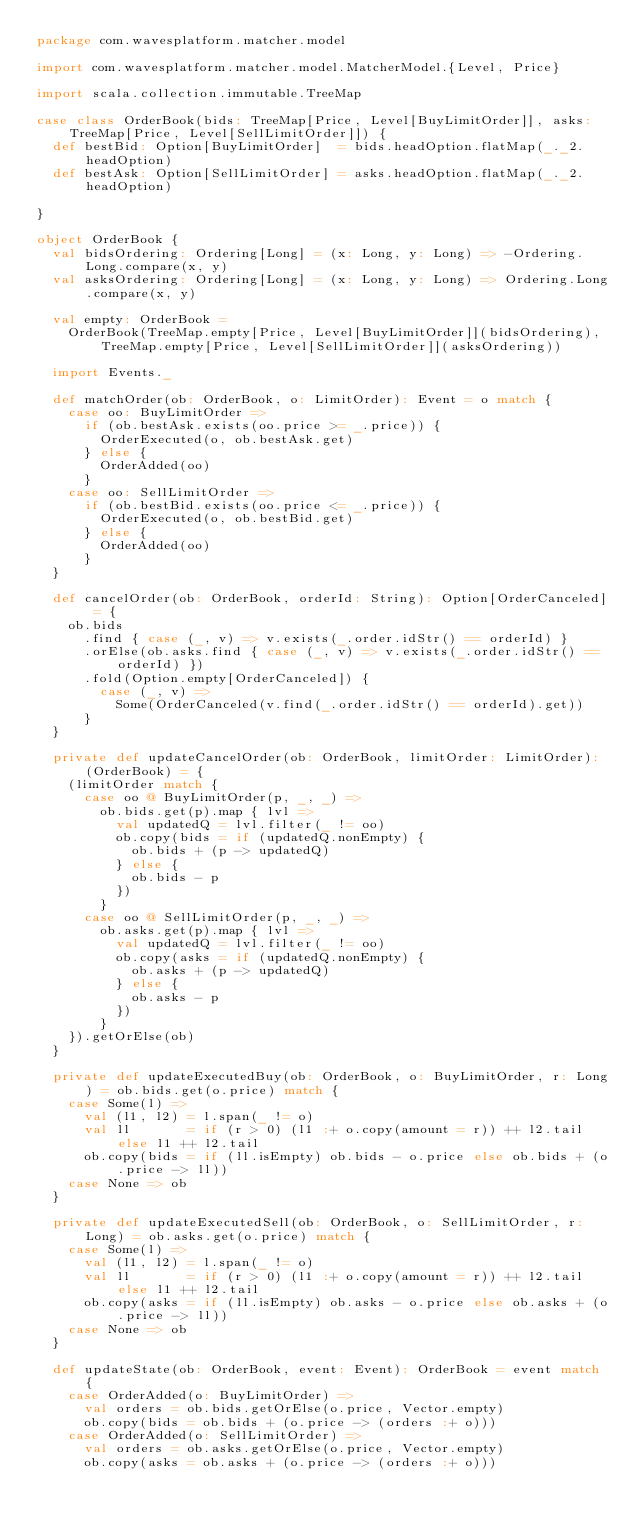<code> <loc_0><loc_0><loc_500><loc_500><_Scala_>package com.wavesplatform.matcher.model

import com.wavesplatform.matcher.model.MatcherModel.{Level, Price}

import scala.collection.immutable.TreeMap

case class OrderBook(bids: TreeMap[Price, Level[BuyLimitOrder]], asks: TreeMap[Price, Level[SellLimitOrder]]) {
  def bestBid: Option[BuyLimitOrder]  = bids.headOption.flatMap(_._2.headOption)
  def bestAsk: Option[SellLimitOrder] = asks.headOption.flatMap(_._2.headOption)

}

object OrderBook {
  val bidsOrdering: Ordering[Long] = (x: Long, y: Long) => -Ordering.Long.compare(x, y)
  val asksOrdering: Ordering[Long] = (x: Long, y: Long) => Ordering.Long.compare(x, y)

  val empty: OrderBook =
    OrderBook(TreeMap.empty[Price, Level[BuyLimitOrder]](bidsOrdering), TreeMap.empty[Price, Level[SellLimitOrder]](asksOrdering))

  import Events._

  def matchOrder(ob: OrderBook, o: LimitOrder): Event = o match {
    case oo: BuyLimitOrder =>
      if (ob.bestAsk.exists(oo.price >= _.price)) {
        OrderExecuted(o, ob.bestAsk.get)
      } else {
        OrderAdded(oo)
      }
    case oo: SellLimitOrder =>
      if (ob.bestBid.exists(oo.price <= _.price)) {
        OrderExecuted(o, ob.bestBid.get)
      } else {
        OrderAdded(oo)
      }
  }

  def cancelOrder(ob: OrderBook, orderId: String): Option[OrderCanceled] = {
    ob.bids
      .find { case (_, v) => v.exists(_.order.idStr() == orderId) }
      .orElse(ob.asks.find { case (_, v) => v.exists(_.order.idStr() == orderId) })
      .fold(Option.empty[OrderCanceled]) {
        case (_, v) =>
          Some(OrderCanceled(v.find(_.order.idStr() == orderId).get))
      }
  }

  private def updateCancelOrder(ob: OrderBook, limitOrder: LimitOrder): (OrderBook) = {
    (limitOrder match {
      case oo @ BuyLimitOrder(p, _, _) =>
        ob.bids.get(p).map { lvl =>
          val updatedQ = lvl.filter(_ != oo)
          ob.copy(bids = if (updatedQ.nonEmpty) {
            ob.bids + (p -> updatedQ)
          } else {
            ob.bids - p
          })
        }
      case oo @ SellLimitOrder(p, _, _) =>
        ob.asks.get(p).map { lvl =>
          val updatedQ = lvl.filter(_ != oo)
          ob.copy(asks = if (updatedQ.nonEmpty) {
            ob.asks + (p -> updatedQ)
          } else {
            ob.asks - p
          })
        }
    }).getOrElse(ob)
  }

  private def updateExecutedBuy(ob: OrderBook, o: BuyLimitOrder, r: Long) = ob.bids.get(o.price) match {
    case Some(l) =>
      val (l1, l2) = l.span(_ != o)
      val ll       = if (r > 0) (l1 :+ o.copy(amount = r)) ++ l2.tail else l1 ++ l2.tail
      ob.copy(bids = if (ll.isEmpty) ob.bids - o.price else ob.bids + (o.price -> ll))
    case None => ob
  }

  private def updateExecutedSell(ob: OrderBook, o: SellLimitOrder, r: Long) = ob.asks.get(o.price) match {
    case Some(l) =>
      val (l1, l2) = l.span(_ != o)
      val ll       = if (r > 0) (l1 :+ o.copy(amount = r)) ++ l2.tail else l1 ++ l2.tail
      ob.copy(asks = if (ll.isEmpty) ob.asks - o.price else ob.asks + (o.price -> ll))
    case None => ob
  }

  def updateState(ob: OrderBook, event: Event): OrderBook = event match {
    case OrderAdded(o: BuyLimitOrder) =>
      val orders = ob.bids.getOrElse(o.price, Vector.empty)
      ob.copy(bids = ob.bids + (o.price -> (orders :+ o)))
    case OrderAdded(o: SellLimitOrder) =>
      val orders = ob.asks.getOrElse(o.price, Vector.empty)
      ob.copy(asks = ob.asks + (o.price -> (orders :+ o)))</code> 